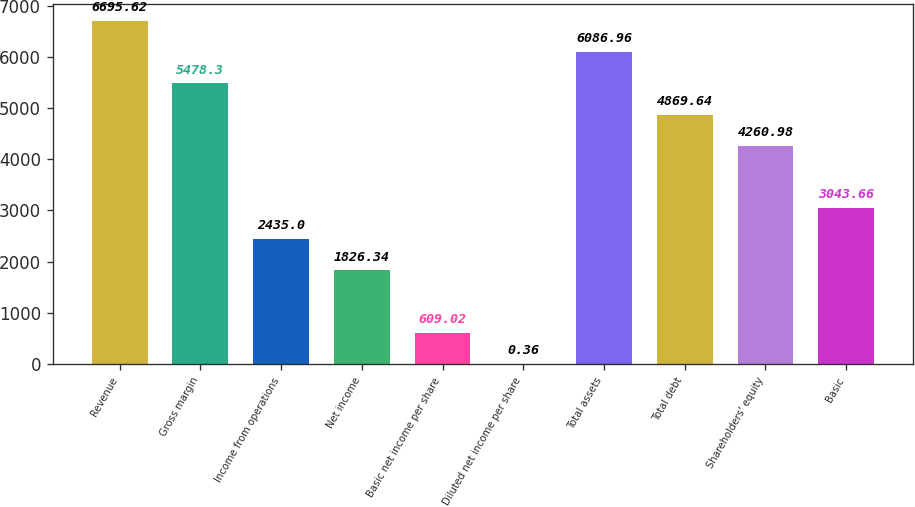<chart> <loc_0><loc_0><loc_500><loc_500><bar_chart><fcel>Revenue<fcel>Gross margin<fcel>Income from operations<fcel>Net income<fcel>Basic net income per share<fcel>Diluted net income per share<fcel>Total assets<fcel>Total debt<fcel>Shareholders' equity<fcel>Basic<nl><fcel>6695.62<fcel>5478.3<fcel>2435<fcel>1826.34<fcel>609.02<fcel>0.36<fcel>6086.96<fcel>4869.64<fcel>4260.98<fcel>3043.66<nl></chart> 